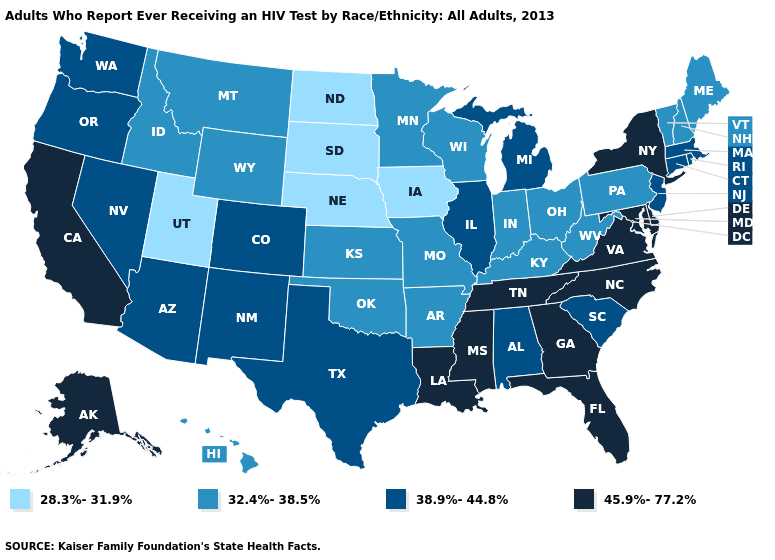Does Missouri have a higher value than Pennsylvania?
Keep it brief. No. What is the highest value in states that border Kentucky?
Be succinct. 45.9%-77.2%. Does Tennessee have the highest value in the USA?
Answer briefly. Yes. What is the lowest value in states that border Arkansas?
Answer briefly. 32.4%-38.5%. What is the value of Pennsylvania?
Write a very short answer. 32.4%-38.5%. What is the value of Maine?
Short answer required. 32.4%-38.5%. What is the value of Oklahoma?
Quick response, please. 32.4%-38.5%. Does Utah have the lowest value in the USA?
Be succinct. Yes. What is the value of Indiana?
Short answer required. 32.4%-38.5%. Which states have the lowest value in the USA?
Quick response, please. Iowa, Nebraska, North Dakota, South Dakota, Utah. What is the highest value in states that border Nebraska?
Be succinct. 38.9%-44.8%. What is the value of Colorado?
Answer briefly. 38.9%-44.8%. Does Alaska have the highest value in the West?
Concise answer only. Yes. What is the value of Missouri?
Write a very short answer. 32.4%-38.5%. Does New Hampshire have a lower value than Pennsylvania?
Answer briefly. No. 